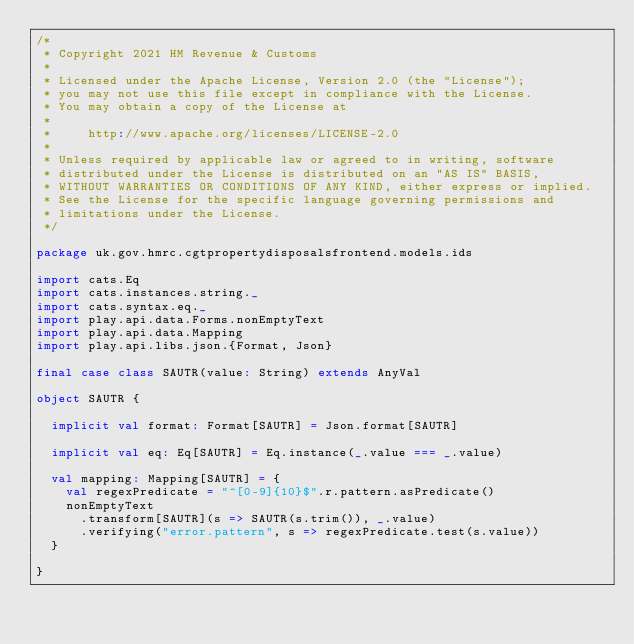<code> <loc_0><loc_0><loc_500><loc_500><_Scala_>/*
 * Copyright 2021 HM Revenue & Customs
 *
 * Licensed under the Apache License, Version 2.0 (the "License");
 * you may not use this file except in compliance with the License.
 * You may obtain a copy of the License at
 *
 *     http://www.apache.org/licenses/LICENSE-2.0
 *
 * Unless required by applicable law or agreed to in writing, software
 * distributed under the License is distributed on an "AS IS" BASIS,
 * WITHOUT WARRANTIES OR CONDITIONS OF ANY KIND, either express or implied.
 * See the License for the specific language governing permissions and
 * limitations under the License.
 */

package uk.gov.hmrc.cgtpropertydisposalsfrontend.models.ids

import cats.Eq
import cats.instances.string._
import cats.syntax.eq._
import play.api.data.Forms.nonEmptyText
import play.api.data.Mapping
import play.api.libs.json.{Format, Json}

final case class SAUTR(value: String) extends AnyVal

object SAUTR {

  implicit val format: Format[SAUTR] = Json.format[SAUTR]

  implicit val eq: Eq[SAUTR] = Eq.instance(_.value === _.value)

  val mapping: Mapping[SAUTR] = {
    val regexPredicate = "^[0-9]{10}$".r.pattern.asPredicate()
    nonEmptyText
      .transform[SAUTR](s => SAUTR(s.trim()), _.value)
      .verifying("error.pattern", s => regexPredicate.test(s.value))
  }

}
</code> 